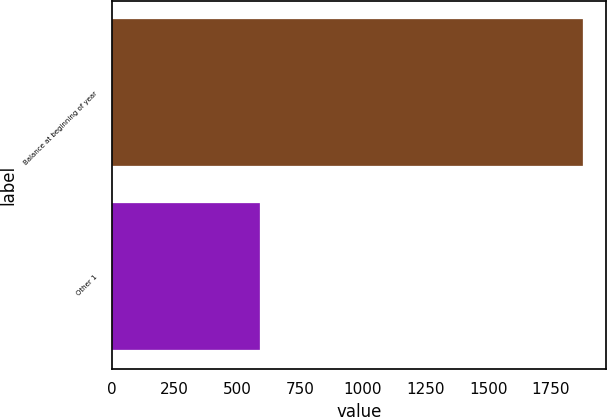Convert chart to OTSL. <chart><loc_0><loc_0><loc_500><loc_500><bar_chart><fcel>Balance at beginning of year<fcel>Other 1<nl><fcel>1877<fcel>588<nl></chart> 